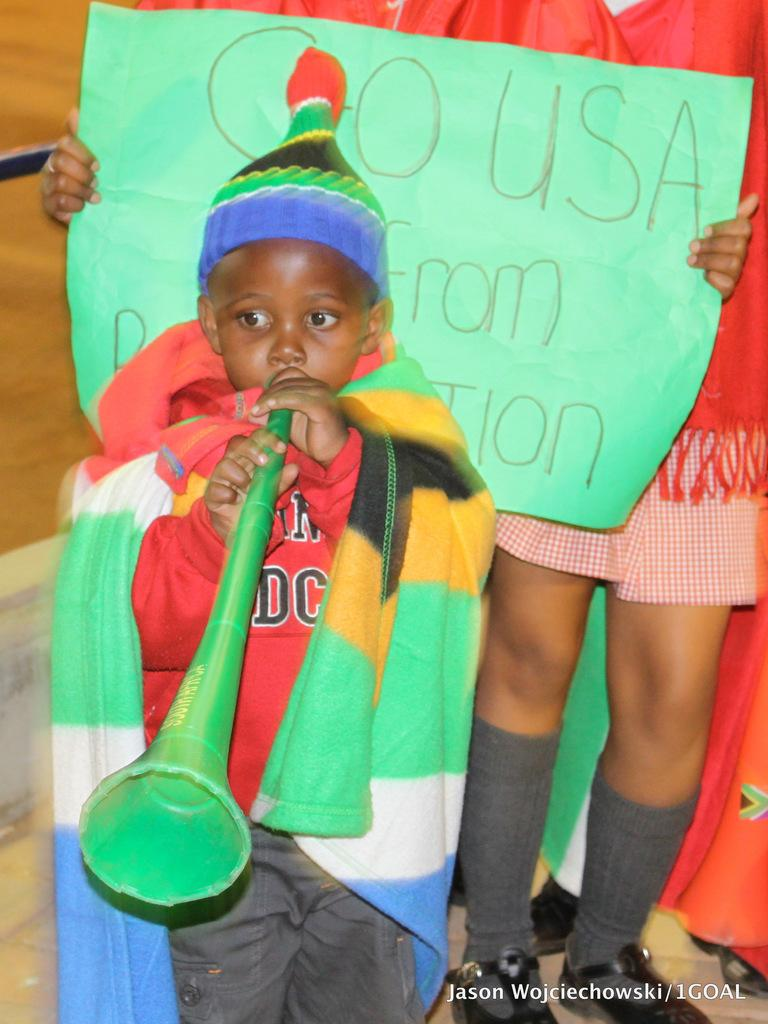Who is the main subject in the image? The main subject in the image is a boy. What is the boy doing in the image? The boy is standing and holding a musical instrument. Can you describe the person next to the boy? There is a person holding a board in the image. Are there any other people visible in the image? A: Yes, there are other people visible in the image. What type of basketball skills is the boy demonstrating in the image? There is no basketball present in the image, so the boy is not demonstrating any basketball skills. How does the person holding the board shake hands with the boy in the image? There is no indication in the image that the person holding the board is shaking hands with the boy. 